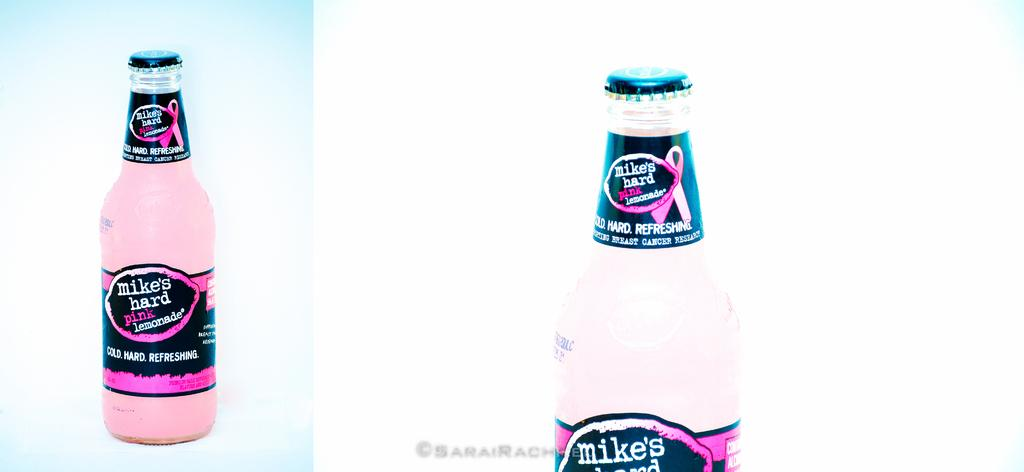Provide a one-sentence caption for the provided image. a bottle of Mikes Hard Lemonade with the cap still on. 